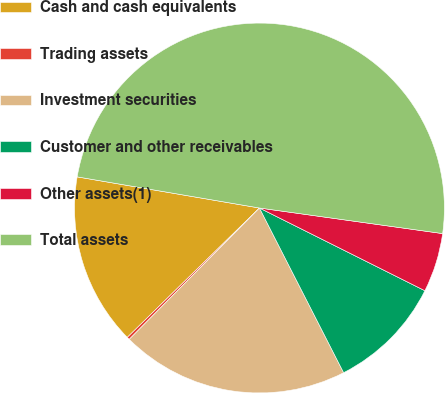Convert chart to OTSL. <chart><loc_0><loc_0><loc_500><loc_500><pie_chart><fcel>Cash and cash equivalents<fcel>Trading assets<fcel>Investment securities<fcel>Customer and other receivables<fcel>Other assets(1)<fcel>Total assets<nl><fcel>15.02%<fcel>0.24%<fcel>19.95%<fcel>10.1%<fcel>5.17%<fcel>49.51%<nl></chart> 